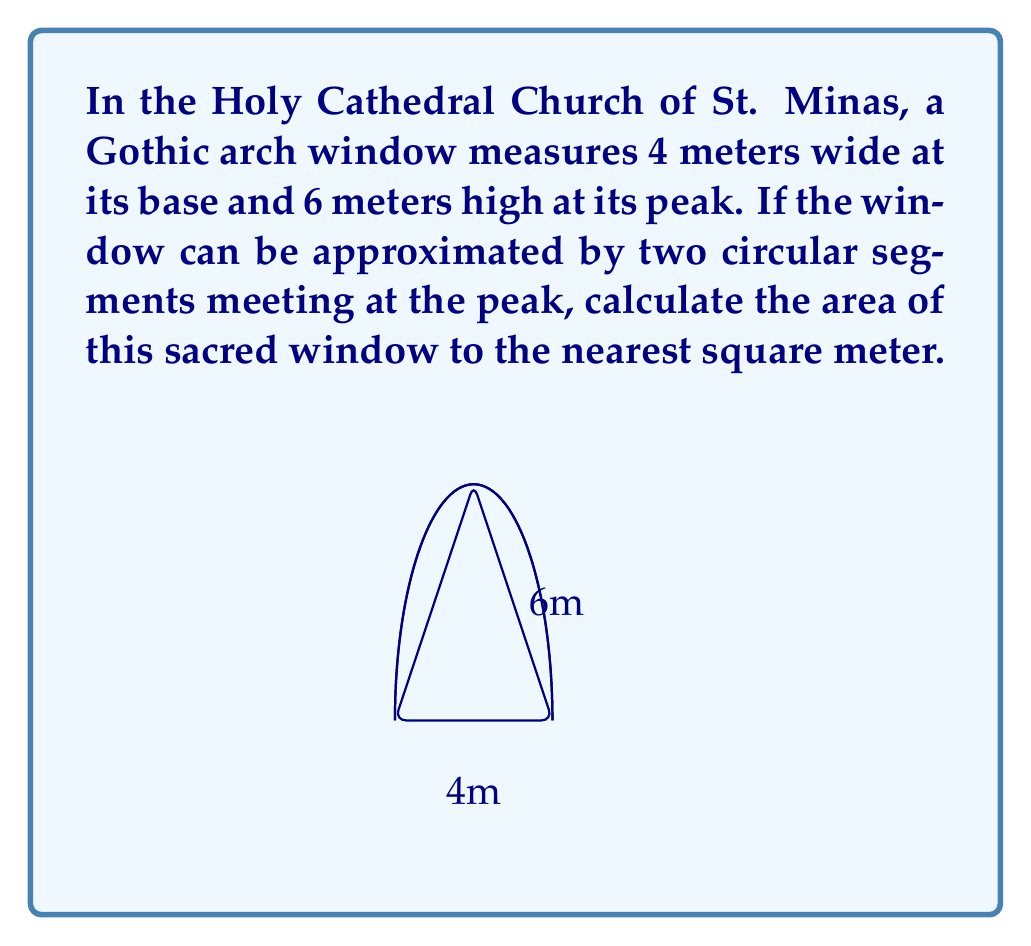What is the answer to this math problem? Let's approach this step-by-step:

1) The Gothic arch is composed of two circular segments. We need to find the area of each segment and add them together.

2) For a circular segment, we use the formula:
   $$ A = r^2 \arccos(\frac{r-h}{r}) - (r-h)\sqrt{2rh-h^2} $$
   where $r$ is the radius of the circle and $h$ is the height of the segment.

3) In our case, the width is 4m and the height is 6m. The radius of each circle can be found using the Pythagorean theorem:
   $$ r^2 = (\frac{4}{2})^2 + (r-6)^2 $$
   $$ r^2 = 4 + r^2 - 12r + 36 $$
   $$ 12r = 40 $$
   $$ r = \frac{10}{3} \approx 3.33 \text{ meters} $$

4) Now we can calculate $h$:
   $$ h = r - (r-6) = 6 - (3.33 - 6) = 8.67 \text{ meters} $$

5) Plugging these values into our segment area formula:
   $$ A = 3.33^2 \arccos(\frac{3.33-8.67}{3.33}) - (3.33-8.67)\sqrt{2(3.33)(8.67)-8.67^2} $$
   $$ A \approx 11.09 - (-5.34)\sqrt{57.85-75.17} $$
   $$ A \approx 11.09 + 9.13 = 20.22 \text{ square meters} $$

6) This is the area of one segment. The total window area is twice this:
   $$ \text{Total Area} = 2 * 20.22 = 40.44 \text{ square meters} $$

7) Rounding to the nearest square meter:
   $$ \text{Total Area} \approx 40 \text{ square meters} $$
Answer: 40 m² 